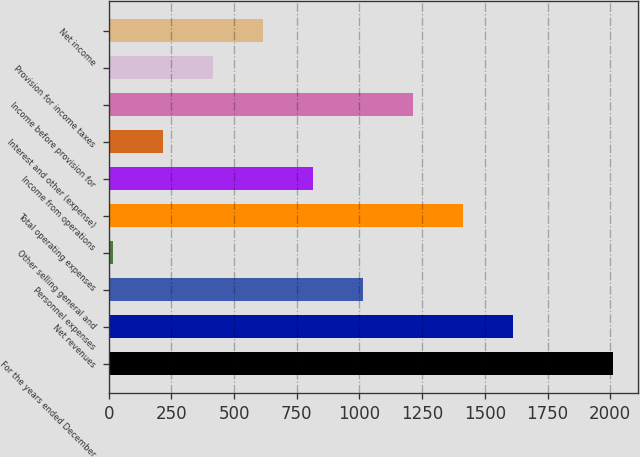Convert chart to OTSL. <chart><loc_0><loc_0><loc_500><loc_500><bar_chart><fcel>For the years ended December<fcel>Net revenues<fcel>Personnel expenses<fcel>Other selling general and<fcel>Total operating expenses<fcel>Income from operations<fcel>Interest and other (expense)<fcel>Income before provision for<fcel>Provision for income taxes<fcel>Net income<nl><fcel>2012<fcel>1612.82<fcel>1014.05<fcel>16.1<fcel>1413.23<fcel>814.46<fcel>215.69<fcel>1213.64<fcel>415.28<fcel>614.87<nl></chart> 